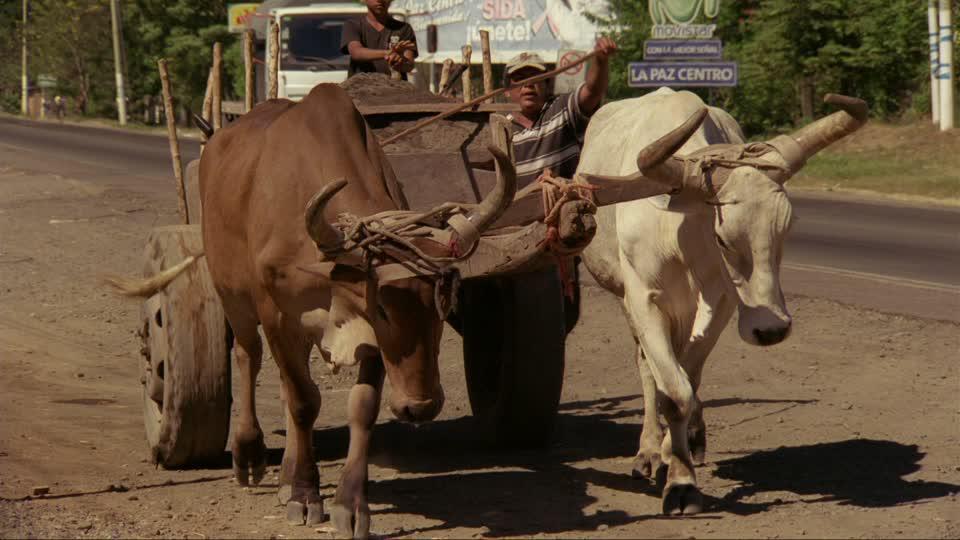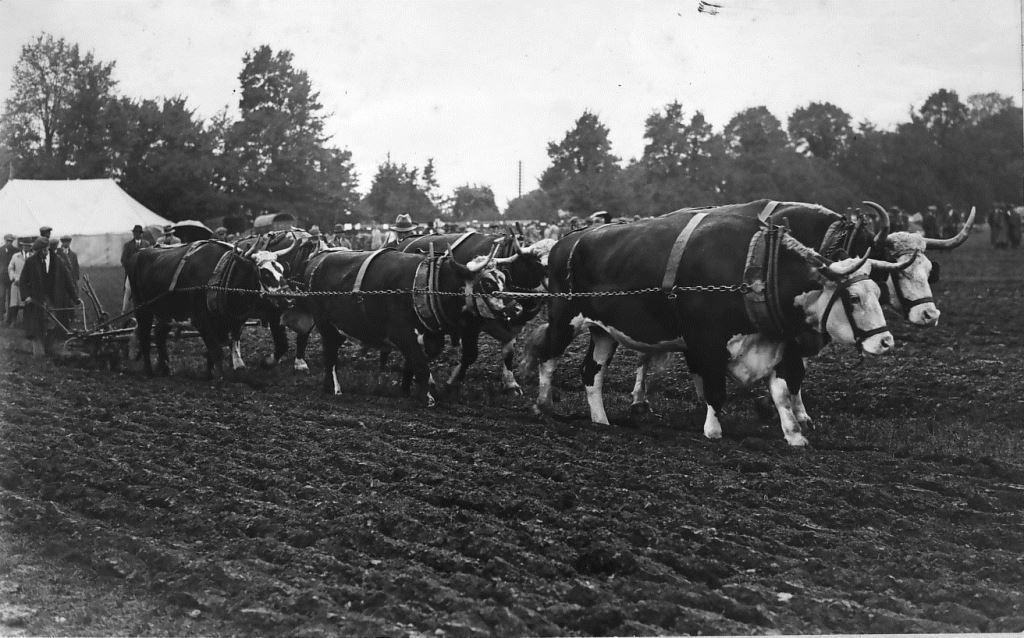The first image is the image on the left, the second image is the image on the right. Considering the images on both sides, is "All the cows in the image are attached to, and pulling, something behind them." valid? Answer yes or no. Yes. The first image is the image on the left, the second image is the image on the right. Examine the images to the left and right. Is the description "All of the animals are walking." accurate? Answer yes or no. Yes. 